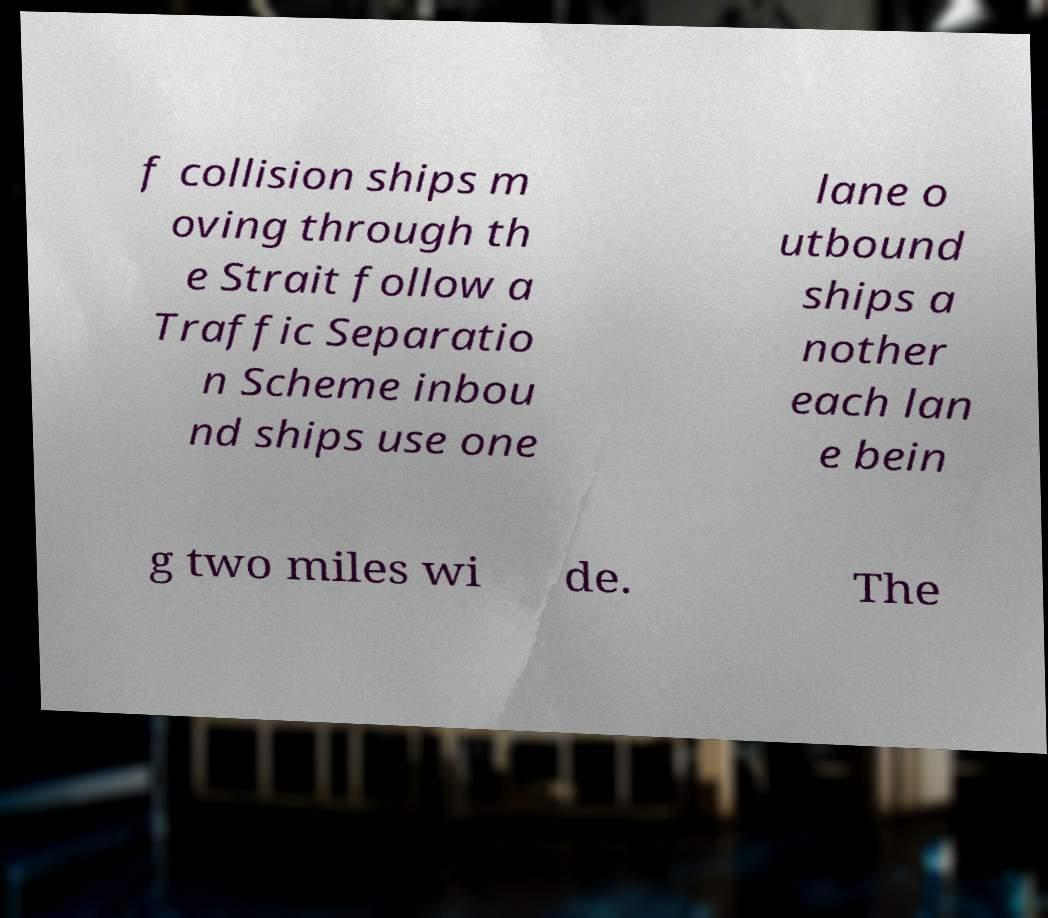There's text embedded in this image that I need extracted. Can you transcribe it verbatim? f collision ships m oving through th e Strait follow a Traffic Separatio n Scheme inbou nd ships use one lane o utbound ships a nother each lan e bein g two miles wi de. The 